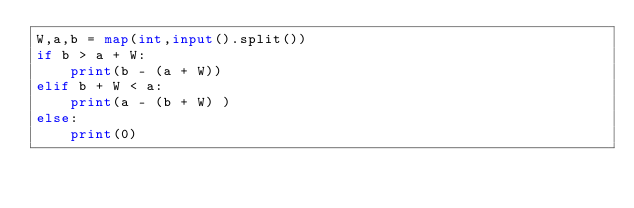<code> <loc_0><loc_0><loc_500><loc_500><_Python_>W,a,b = map(int,input().split())
if b > a + W:
    print(b - (a + W))
elif b + W < a:
    print(a - (b + W) )
else:
    print(0)</code> 